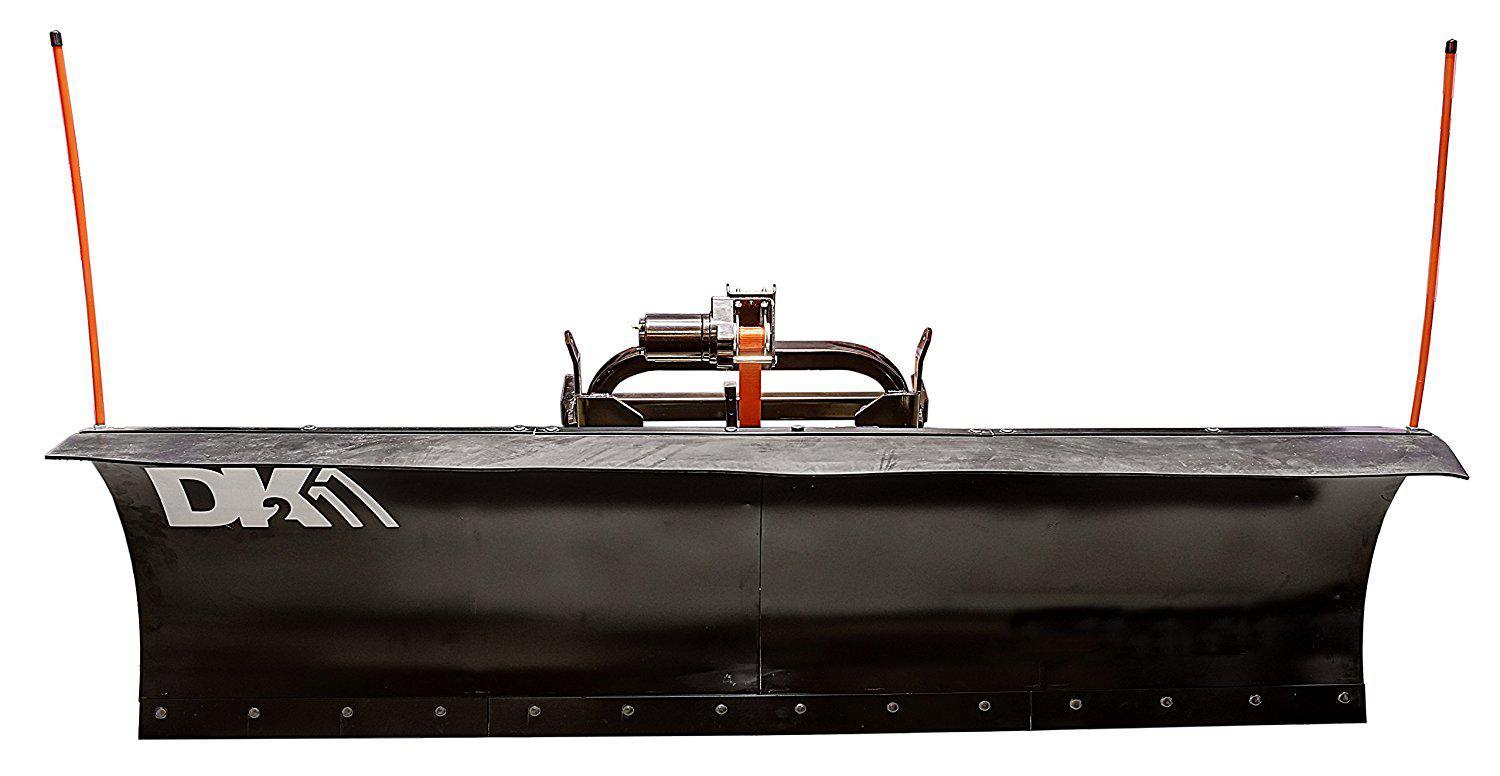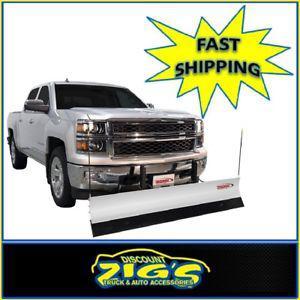The first image is the image on the left, the second image is the image on the right. Evaluate the accuracy of this statement regarding the images: "One image shows a pickup truck angled facing to the right with a plow attachment in front.". Is it true? Answer yes or no. Yes. 